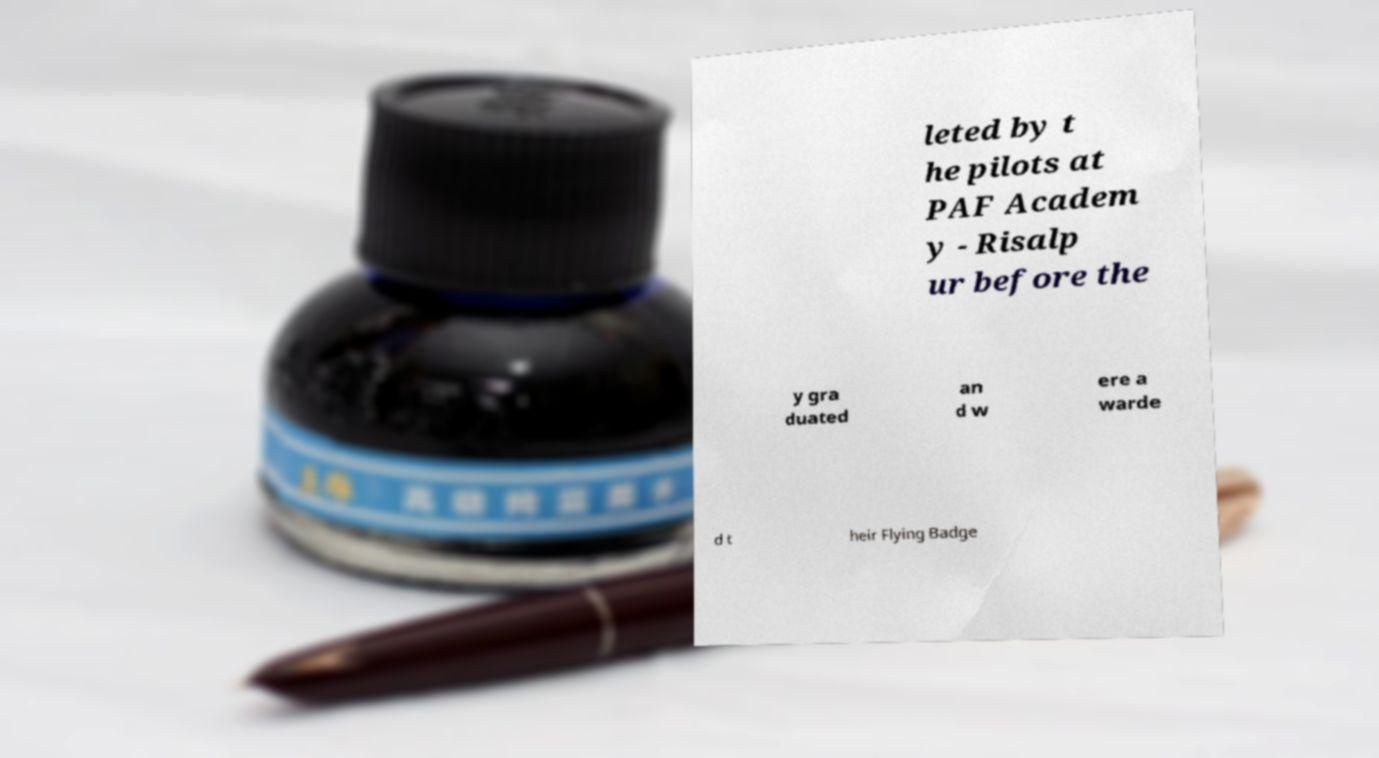For documentation purposes, I need the text within this image transcribed. Could you provide that? leted by t he pilots at PAF Academ y - Risalp ur before the y gra duated an d w ere a warde d t heir Flying Badge 